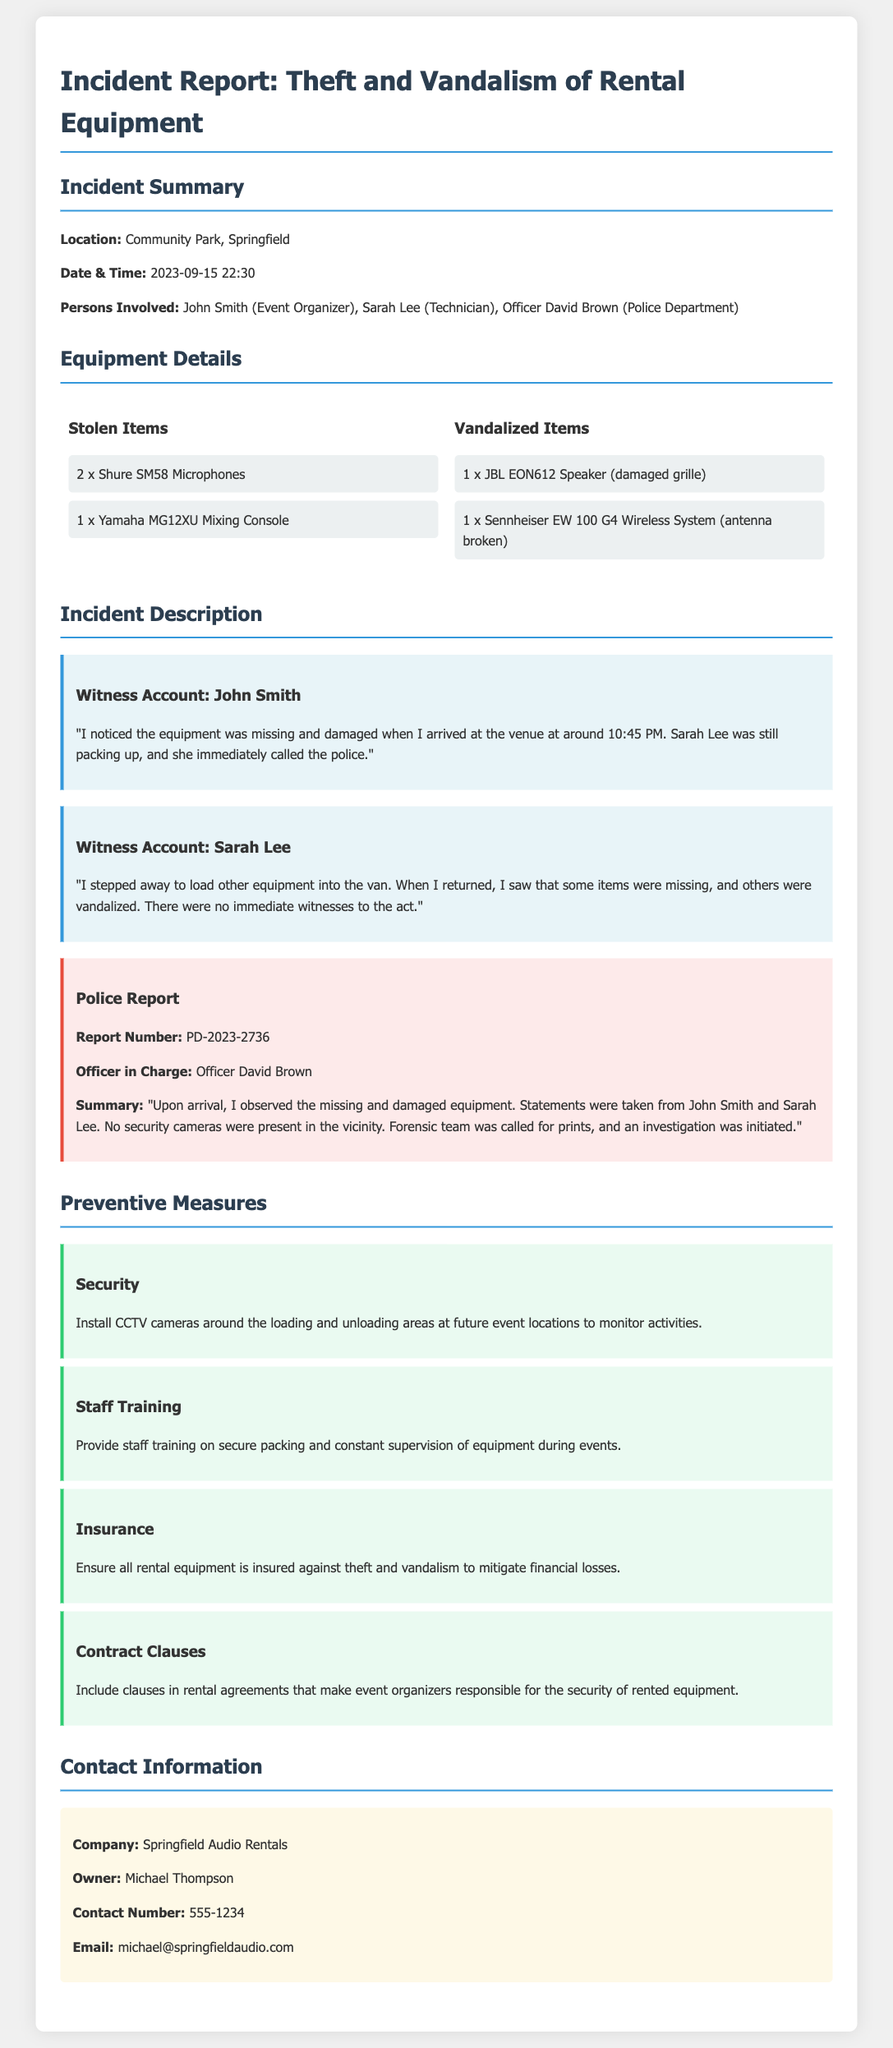What is the location of the incident? The location is specified in the incident summary section of the report.
Answer: Community Park, Springfield Who were the persons involved in the incident? The report lists the individuals involved in the incident.
Answer: John Smith, Sarah Lee, Officer David Brown How many Shure SM58 Microphones were stolen? The number of stolen Shure SM58 Microphones is listed under the equipment details.
Answer: 2 What is the report number? The police report section includes a unique identifier for the case.
Answer: PD-2023-2736 What date and time did the incident occur? The date and time are mentioned in the incident summary.
Answer: 2023-09-15 22:30 What preventive measure involves equipment insurance? One of the preventive measures directly addresses financial security through insurance.
Answer: Insurance How did Sarah Lee account for the vandalism? Sarah Lee's description of the event is detailed in her witness account.
Answer: "When I returned, I saw that some items were missing, and others were vandalized." What training will be provided to staff as a preventive measure? A specific preventive measure discusses staff education related to equipment security.
Answer: Provide staff training on secure packing and constant supervision of equipment during events What was damaged among the equipment listed? The equipment details include specific items that were vandalized.
Answer: 1 x JBL EON612 Speaker (damaged grille) 